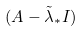Convert formula to latex. <formula><loc_0><loc_0><loc_500><loc_500>( A - \tilde { \lambda } _ { * } I )</formula> 